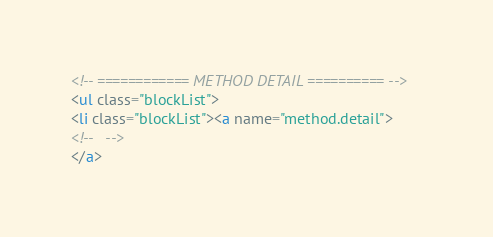Convert code to text. <code><loc_0><loc_0><loc_500><loc_500><_HTML_><!-- ============ METHOD DETAIL ========== -->
<ul class="blockList">
<li class="blockList"><a name="method.detail">
<!--   -->
</a></code> 